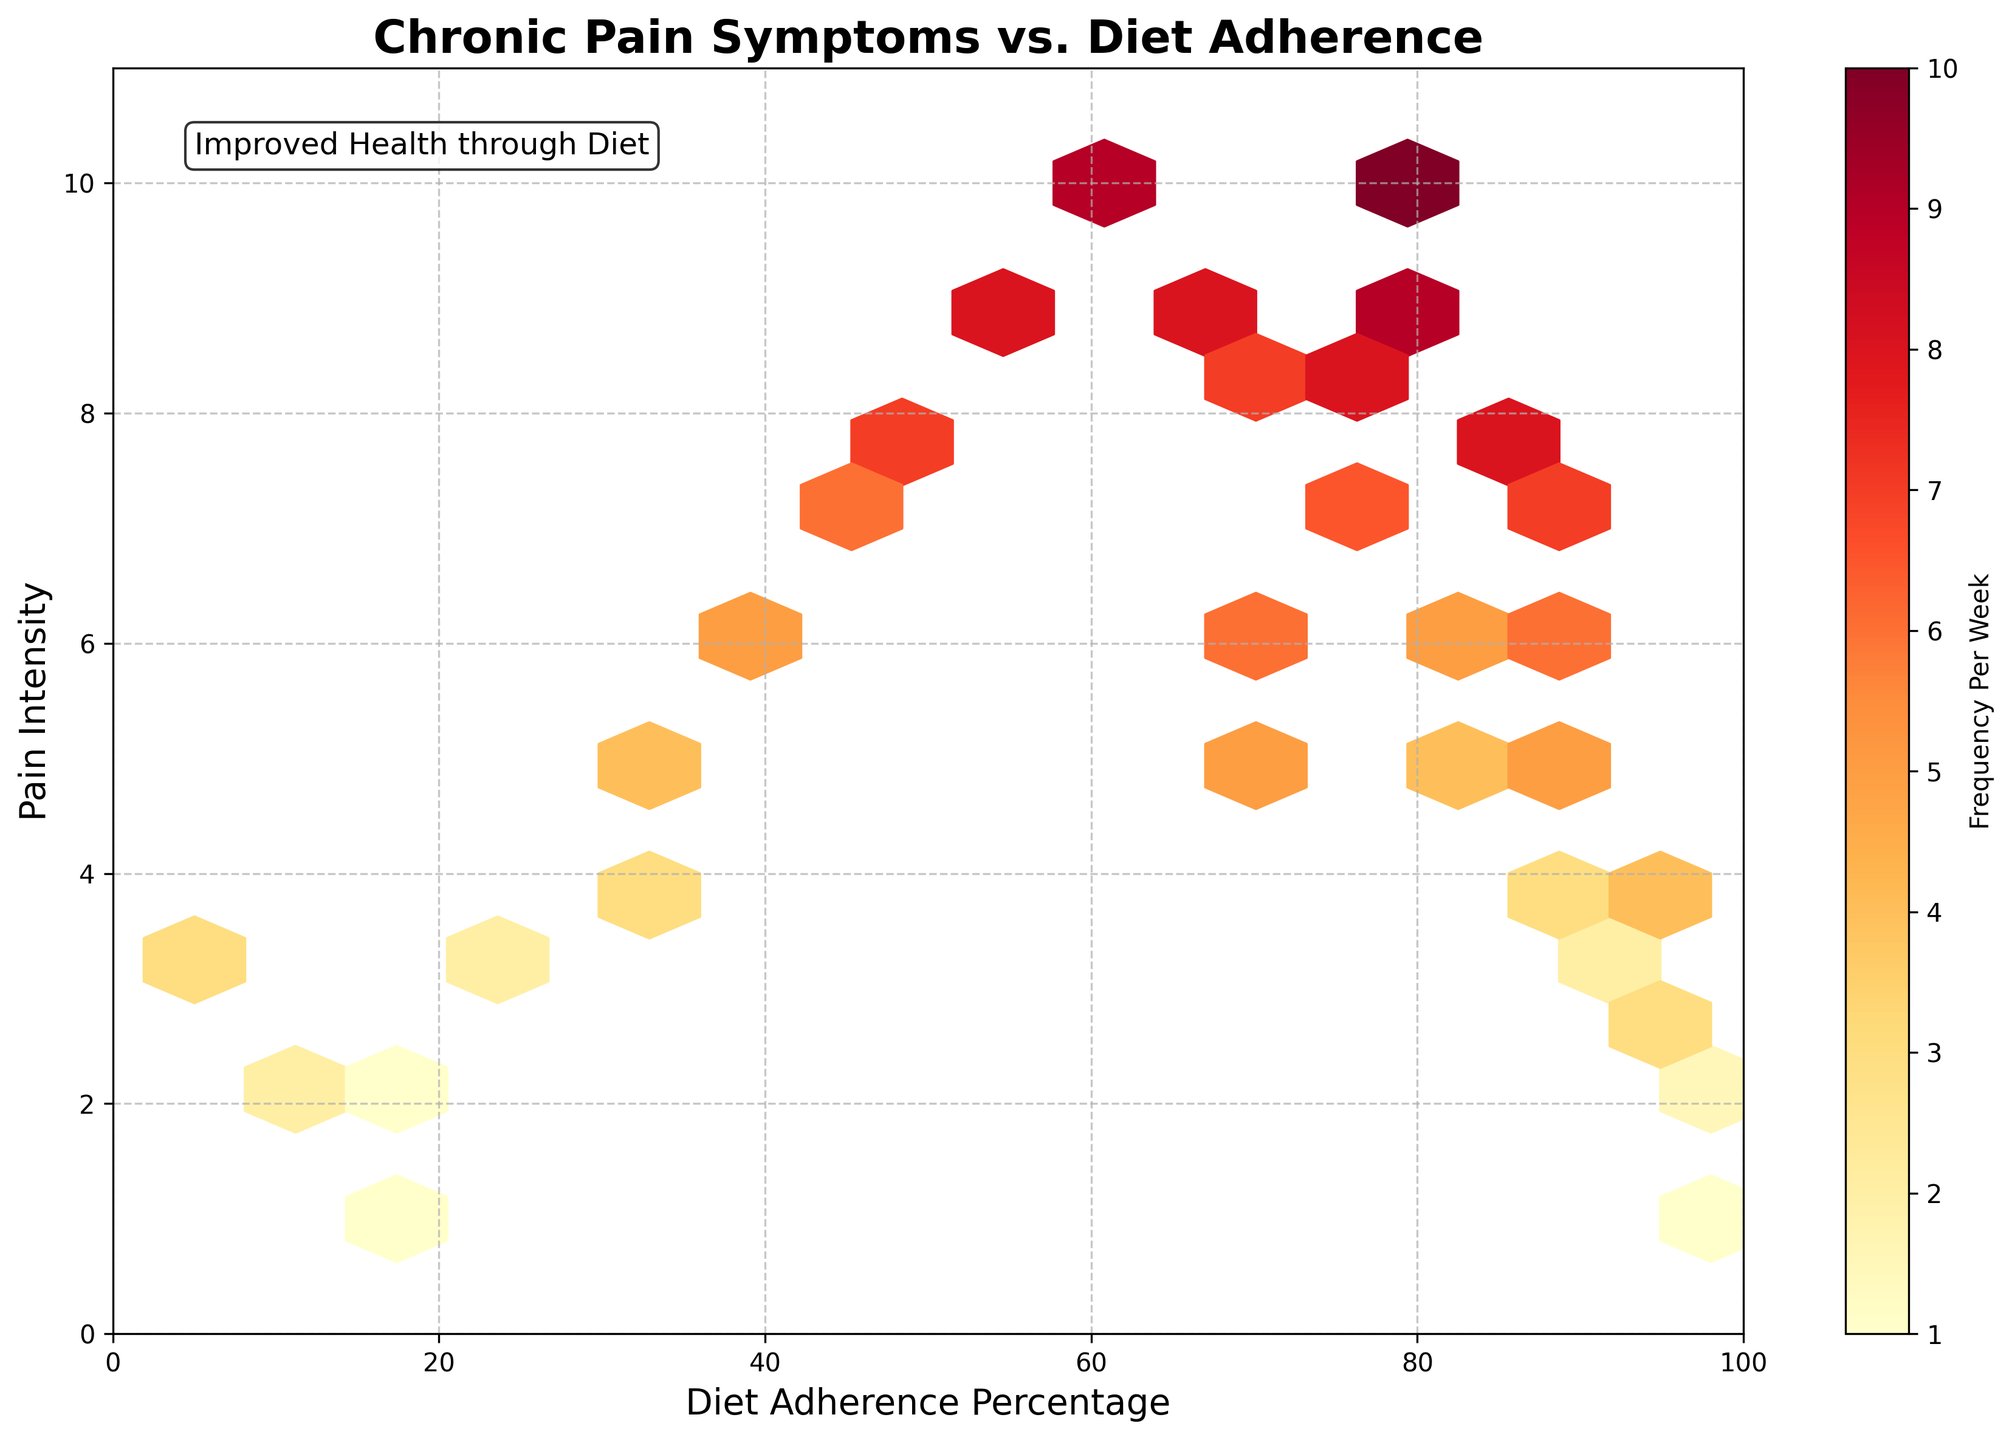What does the title of the plot indicate about the data? The title "Chronic Pain Symptoms vs. Diet Adherence" indicates that the data shows the relationship between how closely individuals adhere to a diet plan and their chronic pain symptoms.
Answer: Relationship between diet adherence and chronic pain symptoms What do the color variations in the plot represent? The color variations in the plot represent the frequency of chronic pain symptoms per week, with different colors indicating different frequency levels.
Answer: Frequency of chronic pain symptoms per week Which axis represents the diet adherence percentage? The x-axis represents the diet adherence percentage, as labeled 'Diet Adherence Percentage'.
Answer: x-axis Where is the highest concentration of data points on the plot? The highest concentration of data points is found where diet adherence percentages are higher, around 80-100%.
Answer: Around 80-100% adherence What pain intensity corresponds with the highest frequency per week according to the color gradient? The highest frequency per week often correlates with higher pain intensities, as indicated by the darker colors like deep yellow and red.
Answer: Higher pain intensities How does the color gradient change as pain intensity increases with low diet adherence? As pain intensity increases with low diet adherence, the color gradient shifts towards darker shades, indicating higher frequencies per week.
Answer: Darker shades (higher frequency) Is there a noticeable pattern between diet adherence and pain intensity? Yes, as diet adherence decreases, pain intensity generally increases, suggesting a negative correlation between adherence and pain intensity.
Answer: Inverse relationship Which adherence percentage shows the lowest pain intensity and frequency per week? The lowest pain intensity and frequency per week are shown at around 98% diet adherence, indicated by the lightest color bin.
Answer: Around 98% adherence How does the pain intensity vary across different adherence percentages? Pain intensity varies significantly across different adherence percentages, generally increasing as the adherence percentage decreases. High adherence (80-100%) is associated with lower pain intensity, while low adherence (20-50%) is associated with higher pain intensity.
Answer: Varies significantly; increases with lower adherence 